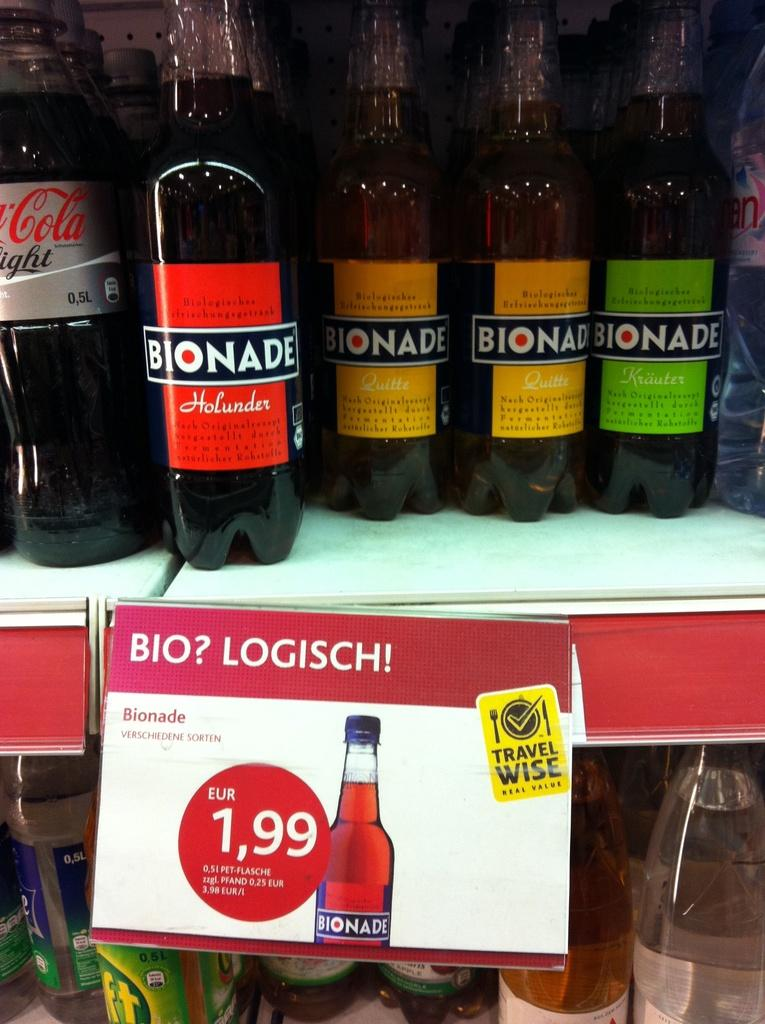<image>
Offer a succinct explanation of the picture presented. A colorful assortment of bottles of Bionade are on a shelf.. 